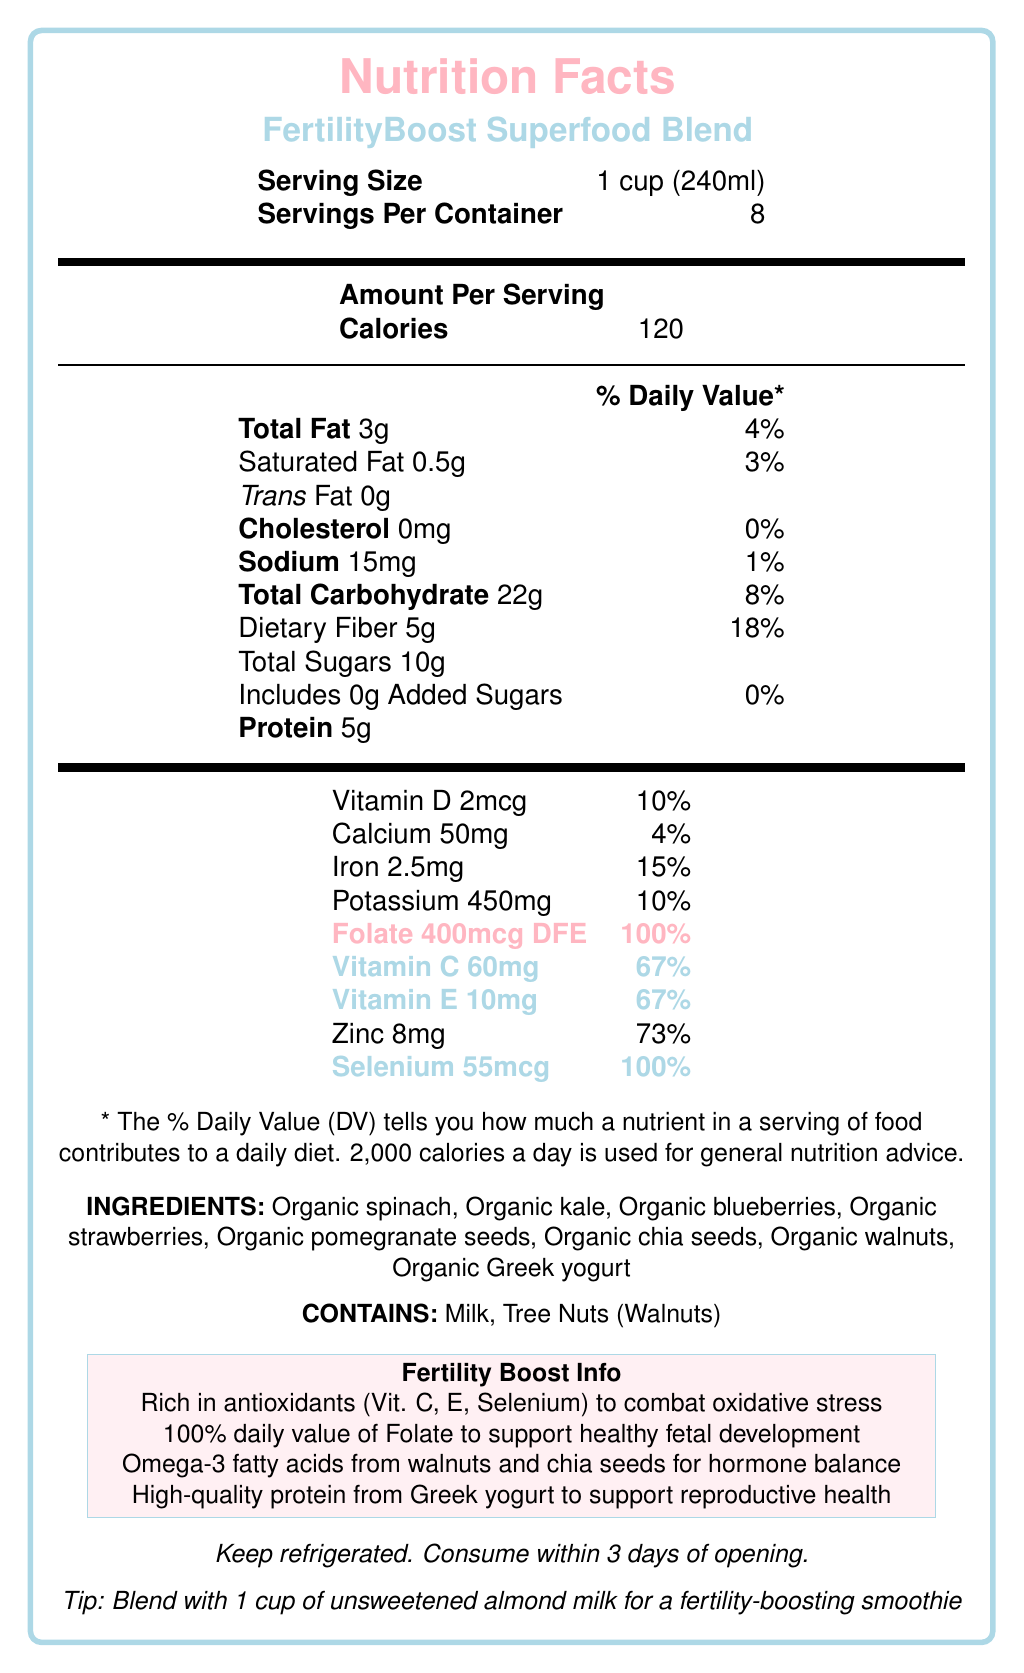what is the serving size? The serving size is listed at the top of the Nutrition Facts section.
Answer: 1 cup (240ml) how much folate is in one serving? The amount of folate per serving is highlighted in pink as 400mcg DFE.
Answer: 400mcg DFE how many servings are in the container? The document states that there are 8 servings per container, located near the top.
Answer: 8 how much protein is in a serving? The protein content per serving is listed under the “Amount Per Serving” section as 5g.
Answer: 5g what are the storage instructions for this product? The storage instructions are listed near the bottom of the document.
Answer: Keep refrigerated. Consume within 3 days of opening. which ingredient is NOT present in the FertilityBoost Superfood Blend? A. Organic spinach B. Organic kale C. Organic quinoa D. Organic Greek yogurt Organic quinoa is not listed in the ingredients section, while the others are.
Answer: C what percentage of the daily value of zinc does one serving provide? A. 10% B. 50% C. 73% D. 100% The zinc content per serving is listed as 73% of the daily value.
Answer: C does the product contain added sugars? The document indicates 0g added sugars under "Total Sugars."
Answer: No is the product suitable for someone with a tree nut allergy? The allergen information states that the product contains tree nuts (walnuts).
Answer: No how would you summarize the document’s main idea? The document details the nutritional content of the FertilityBoost Superfood Blend, its ingredients, fertility-related benefits, and consumption instructions.
Answer: The FertilityBoost Superfood Blend is a nutritionally-rich product designed for those looking to improve fertility. It provides key nutrients like antioxidants and folate, includes a variety of organic ingredients, and offers health benefits for reproductive health. what is the percentage daily value of vitamin D in one serving? The percentage daily value of vitamin D is listed as 10% under the nutritional values.
Answer: 10% how many milligrams of potassium are in one serving? The potassium content is listed under the nutritional values as 450mg.
Answer: 450mg what is the calorie content per serving? The calories per serving is prominently listed as 120.
Answer: 120 calories what kind of fats does the FertilityBoost Superfood Blend provide for hormone balance? The document highlights that the product contains omega-3 fatty acids from walnuts and chia seeds for hormone balance.
Answer: Omega-3 fatty acids where should this product be stored after opening? The document states to keep the product refrigerated and consume within 3 days of opening.
Answer: In the refrigerator which vitamin is provided at 67% of the daily value per serving? A. Vitamin A B. Vitamin C C. Vitamin K D. Vitamin B12 The document shows that vitamin C is provided at 67% of the daily value per serving.
Answer: B how much dietary fiber is there in one serving? The dietary fiber content is listed under the "Total Carbohydrate" section as 5g.
Answer: 5g what does the product suggest blending it with for a smoothie? The bottom of the document offers a preparation tip to blend the product with 1 cup of unsweetened almond milk for a smoothie.
Answer: 1 cup of unsweetened almond milk how is the total carbohydrate content divided in this product? The total carbohydrate content is broken down in the "Total Carbohydrate" section with specific amounts for dietary fiber and total sugars.
Answer: 22g of total carbohydrates, out of which 5g is dietary fiber and 10g is total sugars (including 0g added sugars). can you determine the price of this product from the document? The document does not provide any pricing information.
Answer: Not enough information 